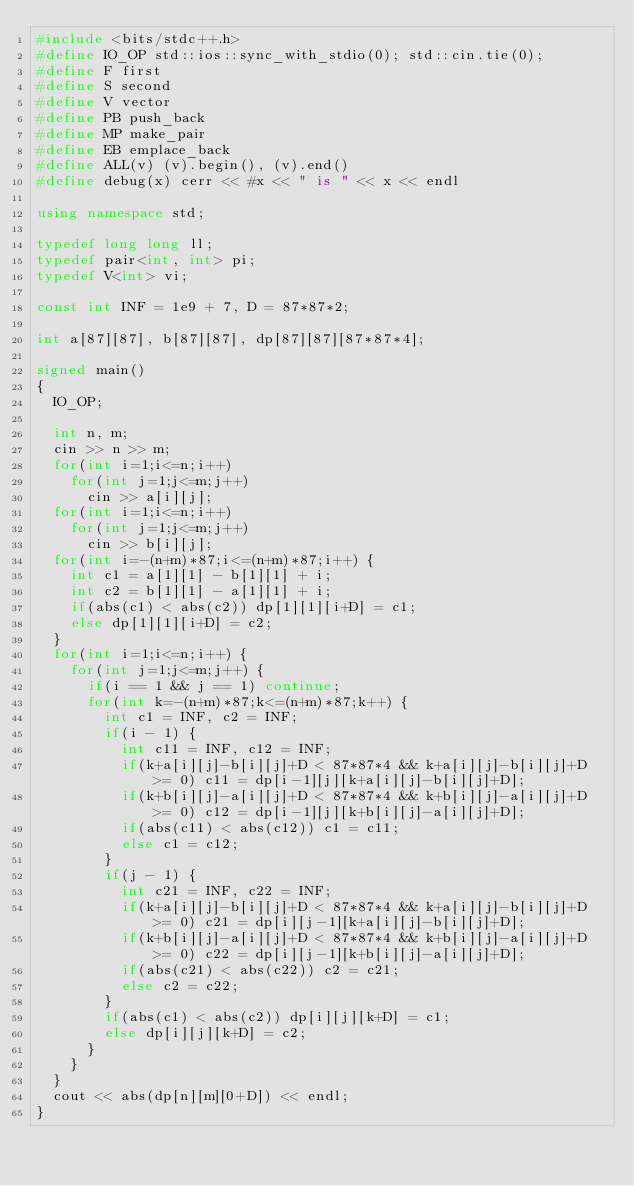<code> <loc_0><loc_0><loc_500><loc_500><_C++_>#include <bits/stdc++.h>
#define IO_OP std::ios::sync_with_stdio(0); std::cin.tie(0);
#define F first
#define S second
#define V vector
#define PB push_back
#define MP make_pair
#define EB emplace_back
#define ALL(v) (v).begin(), (v).end()
#define debug(x) cerr << #x << " is " << x << endl

using namespace std;

typedef long long ll;
typedef pair<int, int> pi;
typedef V<int> vi;

const int INF = 1e9 + 7, D = 87*87*2;

int a[87][87], b[87][87], dp[87][87][87*87*4];

signed main()
{
	IO_OP;
	
	int n, m;
	cin >> n >> m;
	for(int i=1;i<=n;i++)
		for(int j=1;j<=m;j++)
			cin >> a[i][j];
	for(int i=1;i<=n;i++)
		for(int j=1;j<=m;j++)
			cin >> b[i][j];
	for(int i=-(n+m)*87;i<=(n+m)*87;i++) {
		int c1 = a[1][1] - b[1][1] + i;
		int c2 = b[1][1] - a[1][1] + i;
		if(abs(c1) < abs(c2)) dp[1][1][i+D] = c1;
		else dp[1][1][i+D] = c2;
	}
	for(int i=1;i<=n;i++) {
		for(int j=1;j<=m;j++) {
			if(i == 1 && j == 1) continue;
			for(int k=-(n+m)*87;k<=(n+m)*87;k++) {
				int c1 = INF, c2 = INF;
				if(i - 1) {
					int c11 = INF, c12 = INF;
					if(k+a[i][j]-b[i][j]+D < 87*87*4 && k+a[i][j]-b[i][j]+D >= 0) c11 = dp[i-1][j][k+a[i][j]-b[i][j]+D];
					if(k+b[i][j]-a[i][j]+D < 87*87*4 && k+b[i][j]-a[i][j]+D >= 0) c12 = dp[i-1][j][k+b[i][j]-a[i][j]+D];
					if(abs(c11) < abs(c12)) c1 = c11;
					else c1 = c12;
				}
				if(j - 1) {
					int c21 = INF, c22 = INF;
					if(k+a[i][j]-b[i][j]+D < 87*87*4 && k+a[i][j]-b[i][j]+D >= 0) c21 = dp[i][j-1][k+a[i][j]-b[i][j]+D];
					if(k+b[i][j]-a[i][j]+D < 87*87*4 && k+b[i][j]-a[i][j]+D >= 0) c22 = dp[i][j-1][k+b[i][j]-a[i][j]+D];
					if(abs(c21) < abs(c22)) c2 = c21;
					else c2 = c22;
				}
				if(abs(c1) < abs(c2)) dp[i][j][k+D] = c1;
				else dp[i][j][k+D] = c2;
			}
		}
	}
	cout << abs(dp[n][m][0+D]) << endl;
}



	</code> 